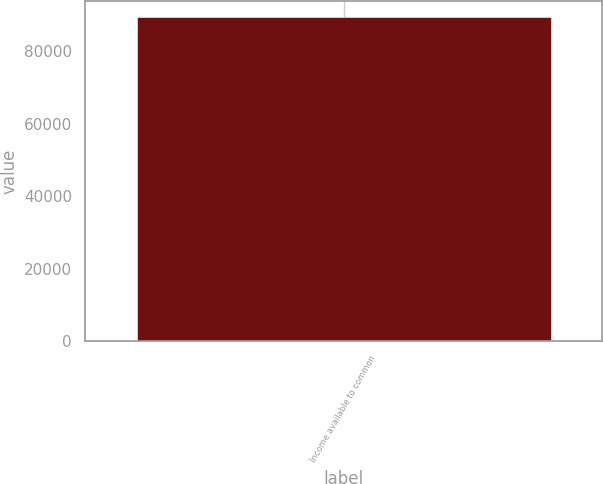Convert chart to OTSL. <chart><loc_0><loc_0><loc_500><loc_500><bar_chart><fcel>Income available to common<nl><fcel>89385.1<nl></chart> 